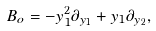<formula> <loc_0><loc_0><loc_500><loc_500>B _ { o } = - y _ { 1 } ^ { 2 } \partial _ { y _ { 1 } } + y _ { 1 } \partial _ { y _ { 2 } } ,</formula> 